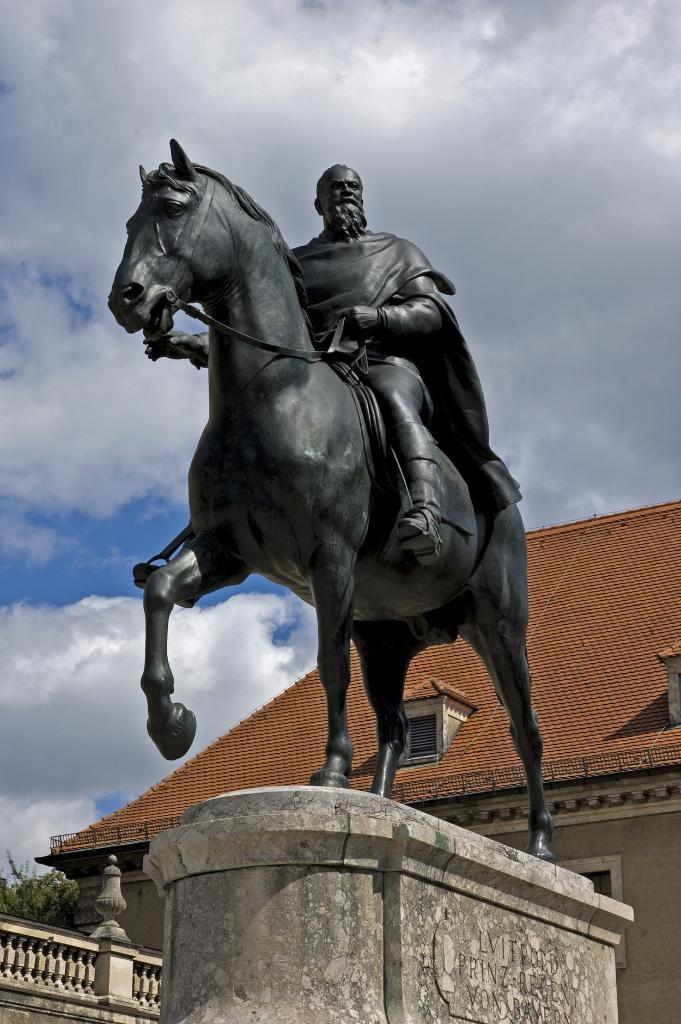What is the main subject of the image? There is a statue of a man sitting on a horse in the image. What is the color of the statue? The color of the statue is black. What can be seen behind the statue? There is a house behind the statue. How would you describe the sky in the image? The sky is cloudy in the image. How many pigs are swimming in the harbor in the image? There is no harbor or pigs present in the image. 